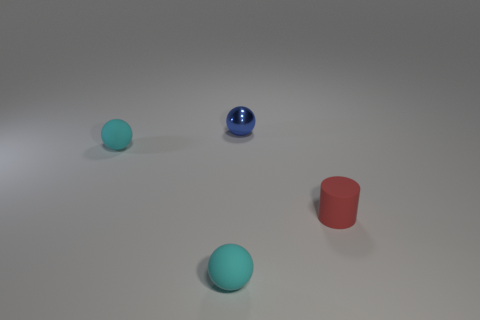Subtract all tiny blue spheres. How many spheres are left? 2 Subtract all red cylinders. How many cyan spheres are left? 2 Add 2 tiny cylinders. How many objects exist? 6 Subtract all cyan balls. How many balls are left? 1 Subtract all brown balls. Subtract all green cylinders. How many balls are left? 3 Subtract all cylinders. How many objects are left? 3 Subtract all tiny cylinders. Subtract all small metal things. How many objects are left? 2 Add 4 tiny rubber spheres. How many tiny rubber spheres are left? 6 Add 2 tiny green cubes. How many tiny green cubes exist? 2 Subtract 0 purple spheres. How many objects are left? 4 